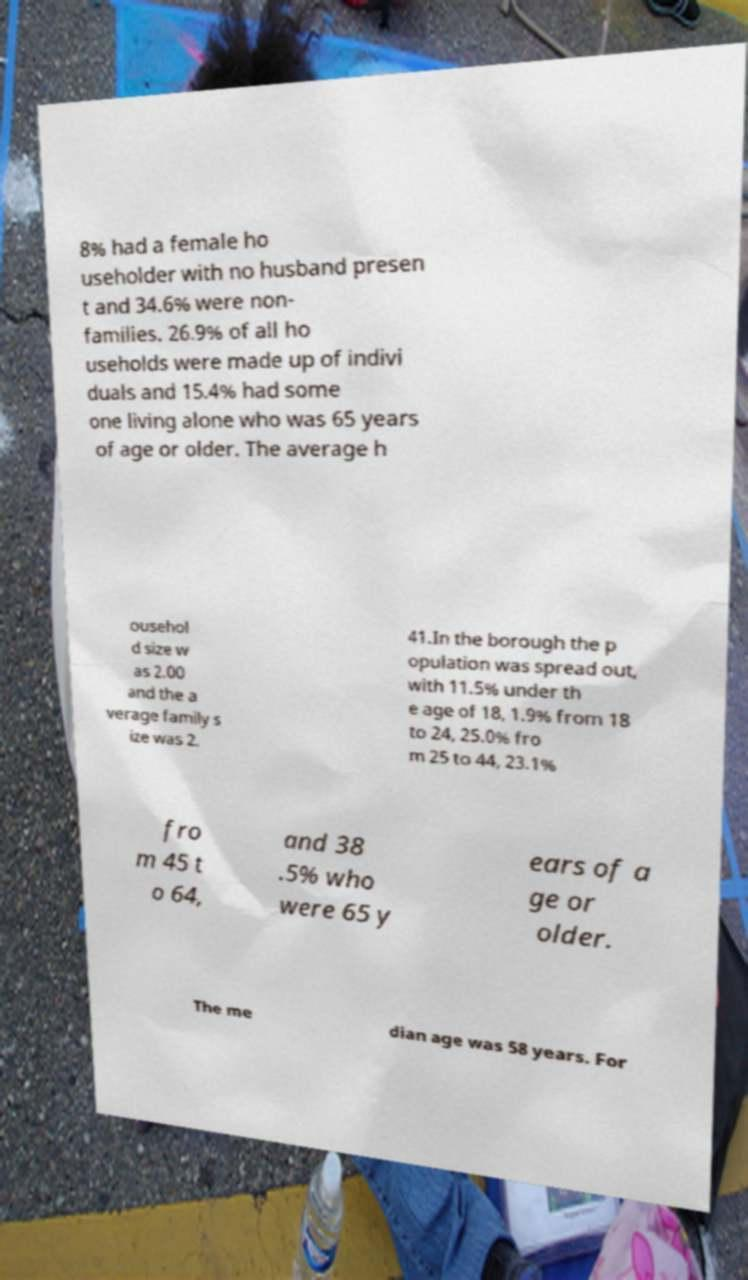Can you accurately transcribe the text from the provided image for me? 8% had a female ho useholder with no husband presen t and 34.6% were non- families. 26.9% of all ho useholds were made up of indivi duals and 15.4% had some one living alone who was 65 years of age or older. The average h ousehol d size w as 2.00 and the a verage family s ize was 2. 41.In the borough the p opulation was spread out, with 11.5% under th e age of 18, 1.9% from 18 to 24, 25.0% fro m 25 to 44, 23.1% fro m 45 t o 64, and 38 .5% who were 65 y ears of a ge or older. The me dian age was 58 years. For 